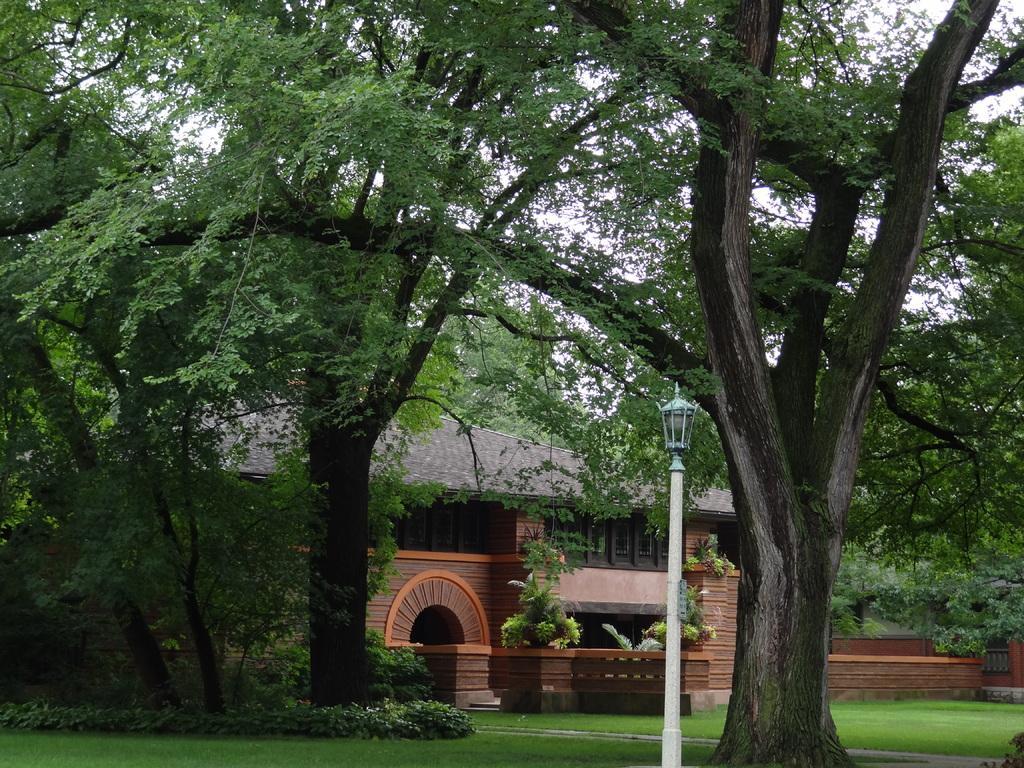Please provide a concise description of this image. This picture is clicked outside. In the foreground we can see the green grass, plants, lamp post and we can see the trees and a house. In the background we can see the sky and some other objects. 